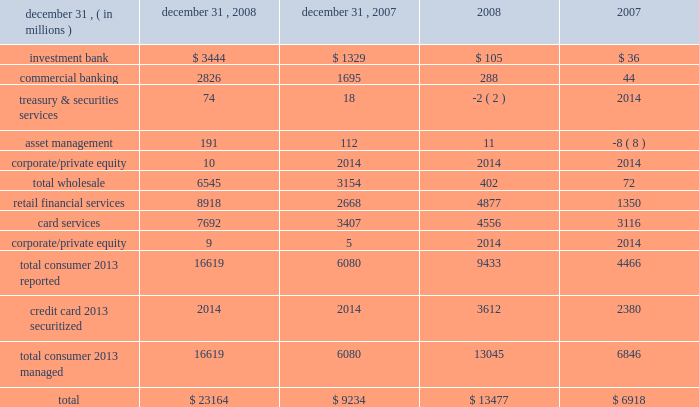Management 2019s discussion and analysis 110 jpmorgan chase & co .
/ 2008 annual report the allowance for credit losses increased $ 13.7 billion from the prior year to $ 23.8 billion .
The increase included $ 4.1 billion of allowance related to noncredit-impaired loans acquired in the washington mutual transaction and the related accounting conformity provision .
Excluding held-for-sale loans , loans carried at fair value , and pur- chased credit-impaired consumer loans , the allowance for loan losses represented 3.62% ( 3.62 % ) of loans at december 31 , 2008 , compared with 1.88% ( 1.88 % ) at december 31 , 2007 .
The consumer allowance for loan losses increased $ 10.5 billion from the prior year as a result of the washington mutual transaction and increased allowance for loan loss in residential real estate and credit card .
The increase included additions to the allowance for loan losses of $ 4.7 billion driven by higher estimated losses for residential mort- gage and home equity loans as the weak labor market and weak overall economic conditions have resulted in increased delinquencies , while continued weak housing prices have driven a significant increase in loss severity .
The allowance for loan losses related to credit card increased $ 4.3 billion from the prior year primarily due to the acquired allowance and subsequent conforming provision for loan loss related to the washington mutual bank acquisition and an increase in provision for loan losses of $ 2.3 billion in 2008 over 2007 , as higher estimated net charge-offs are expected in the port- folio resulting from the current economic conditions .
The wholesale allowance for loan losses increase of $ 3.4 billion from december 31 , 2007 , reflected the effect of a weakening credit envi- ronment and the transfer of $ 4.9 billion of funded and unfunded leveraged lending commitments to retained loans from held-for-sale .
To provide for the risk of loss inherent in the firm 2019s process of extending credit , an allowance for lending-related commitments is held for both wholesale and consumer , which is reported in other lia- bilities .
The wholesale component is computed using a methodology similar to that used for the wholesale loan portfolio , modified for expected maturities and probabilities of drawdown and has an asset- specific component and a formula-based component .
For a further discussion on the allowance for lending-related commitment see note 15 on pages 178 2013180 of this annual report .
The allowance for lending-related commitments for both wholesale and consumer was $ 659 million and $ 850 million at december 31 , 2008 and 2007 , respectively .
The decrease reflects the reduction in lending-related commitments at december 31 , 2008 .
For more information , see page 102 of this annual report .
The table presents the allowance for loan losses and net charge-offs ( recoveries ) by business segment at december 31 , 2008 and 2007 .
Net charge-offs ( recoveries ) december 31 , allowance for loan losses year ended .

What was the percentage change in net charge-offs relating to commercial banking between 2007 and 2008? 
Computations: ((2826 - 1695) / 1695)
Answer: 0.66726. 